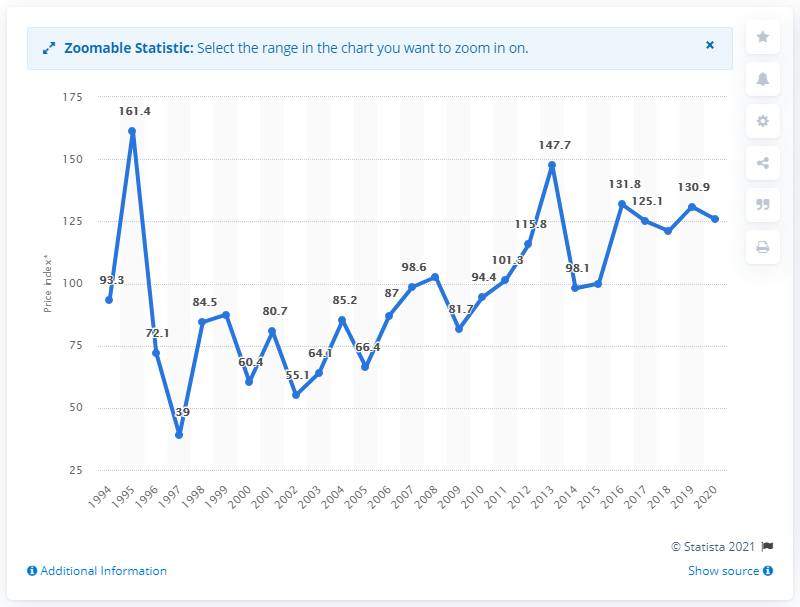List a handful of essential elements in this visual. In 2013, the price index for potatoes was 147.7. 